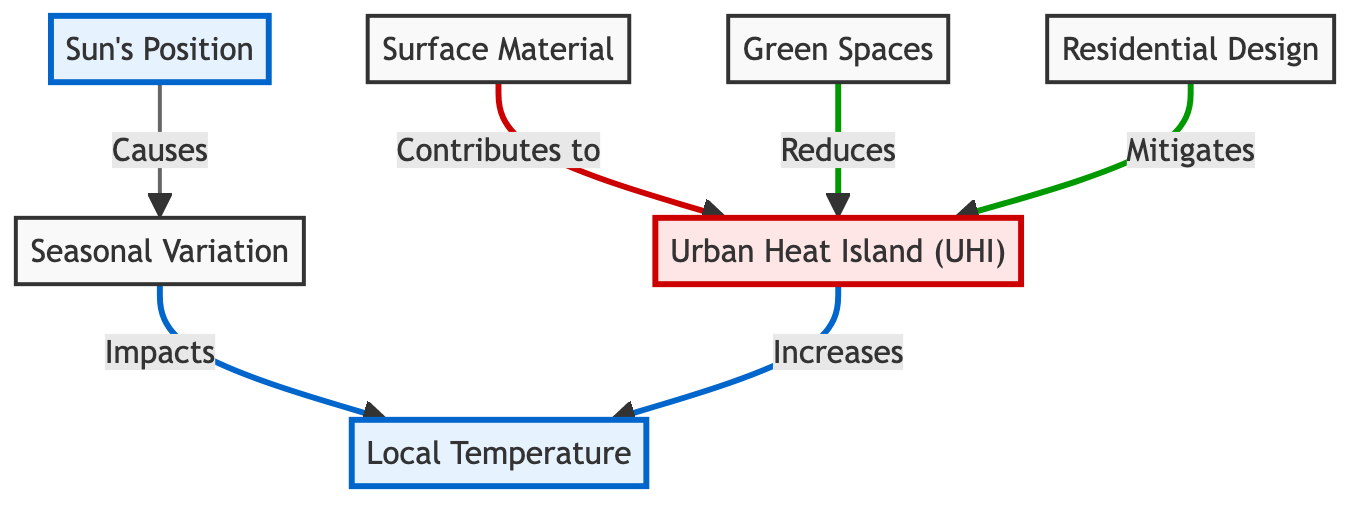What causes seasonal variation? The diagram indicates that the position of the sun causes seasonal variation. This relationship is directly shown through the arrow connecting the sun's position to seasonal variation.
Answer: Sun's Position How many elements impact local temperature? Local temperature is impacted by three elements: seasonal variation, urban heat island (UHI), and residential design. Each of these elements has a connection leading to local temperature, indicating their influence.
Answer: Three Which factor is shown to reduce urban heat island effect? Green spaces are depicted as the factor that reduces urban heat island effect in the diagram. This is indicated by the arrow connecting green spaces to urban heat island which states this contribution.
Answer: Green Spaces What increases local temperature according to the diagram? The diagram shows that urban heat island (UHI) increases local temperature as indicated by the arrow pointing from UHI to local temperature with the label "Increases."
Answer: Urban Heat Island Which surface material contributes to urban heat island? The diagram does not specify a particular surface material but indicates that surface material in general contributes to urban heat island. This is shown through the arrow connecting surface material to urban heat island with the label "Contributes to."
Answer: Surface Material What is the relationship between seasonal variation and local temperature? According to the diagram, seasonal variation impacts local temperature. The connection is indicated by the arrow labeled "Impacts" from seasonal variation to local temperature.
Answer: Impacts What are the elements connected to urban heat island? Two elements are connected to urban heat island: surface material and green spaces. Surface material contributes to UHI and green spaces reduce UHI. The diagram shows arrows leading to and from UHI representing these relationships.
Answer: Surface Material, Green Spaces What is a mitigation strategy for urban heat island? The mitigation strategy for urban heat island is residential design as indicated by the contribution from residential design to urban heat island in the diagram. This is shown through the corresponding arrow.
Answer: Residential Design 